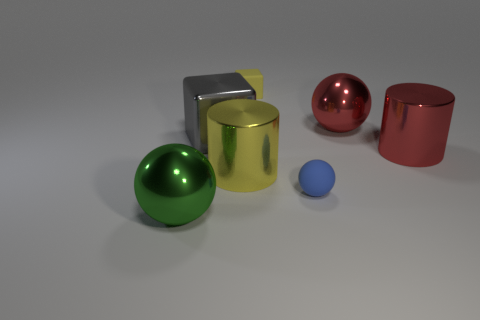There is a thing that is the same color as the tiny rubber cube; what is its material?
Offer a very short reply. Metal. There is a large gray thing that is the same shape as the small yellow object; what material is it?
Provide a succinct answer. Metal. What color is the sphere that is both in front of the large shiny cube and on the right side of the small yellow rubber thing?
Keep it short and to the point. Blue. Are there more blocks in front of the yellow cube than large red things that are on the left side of the big red shiny sphere?
Provide a short and direct response. Yes. Does the cylinder to the left of the red cylinder have the same size as the gray shiny object?
Your answer should be very brief. Yes. How many blue rubber spheres are right of the block on the right side of the yellow cylinder that is right of the green shiny ball?
Your response must be concise. 1. What size is the ball that is on the right side of the yellow cube and in front of the large red cylinder?
Your answer should be very brief. Small. How many other objects are there of the same shape as the gray thing?
Give a very brief answer. 1. How many metal objects are right of the small rubber sphere?
Make the answer very short. 2. Are there fewer tiny matte spheres that are behind the large green shiny object than big things in front of the gray block?
Make the answer very short. Yes. 